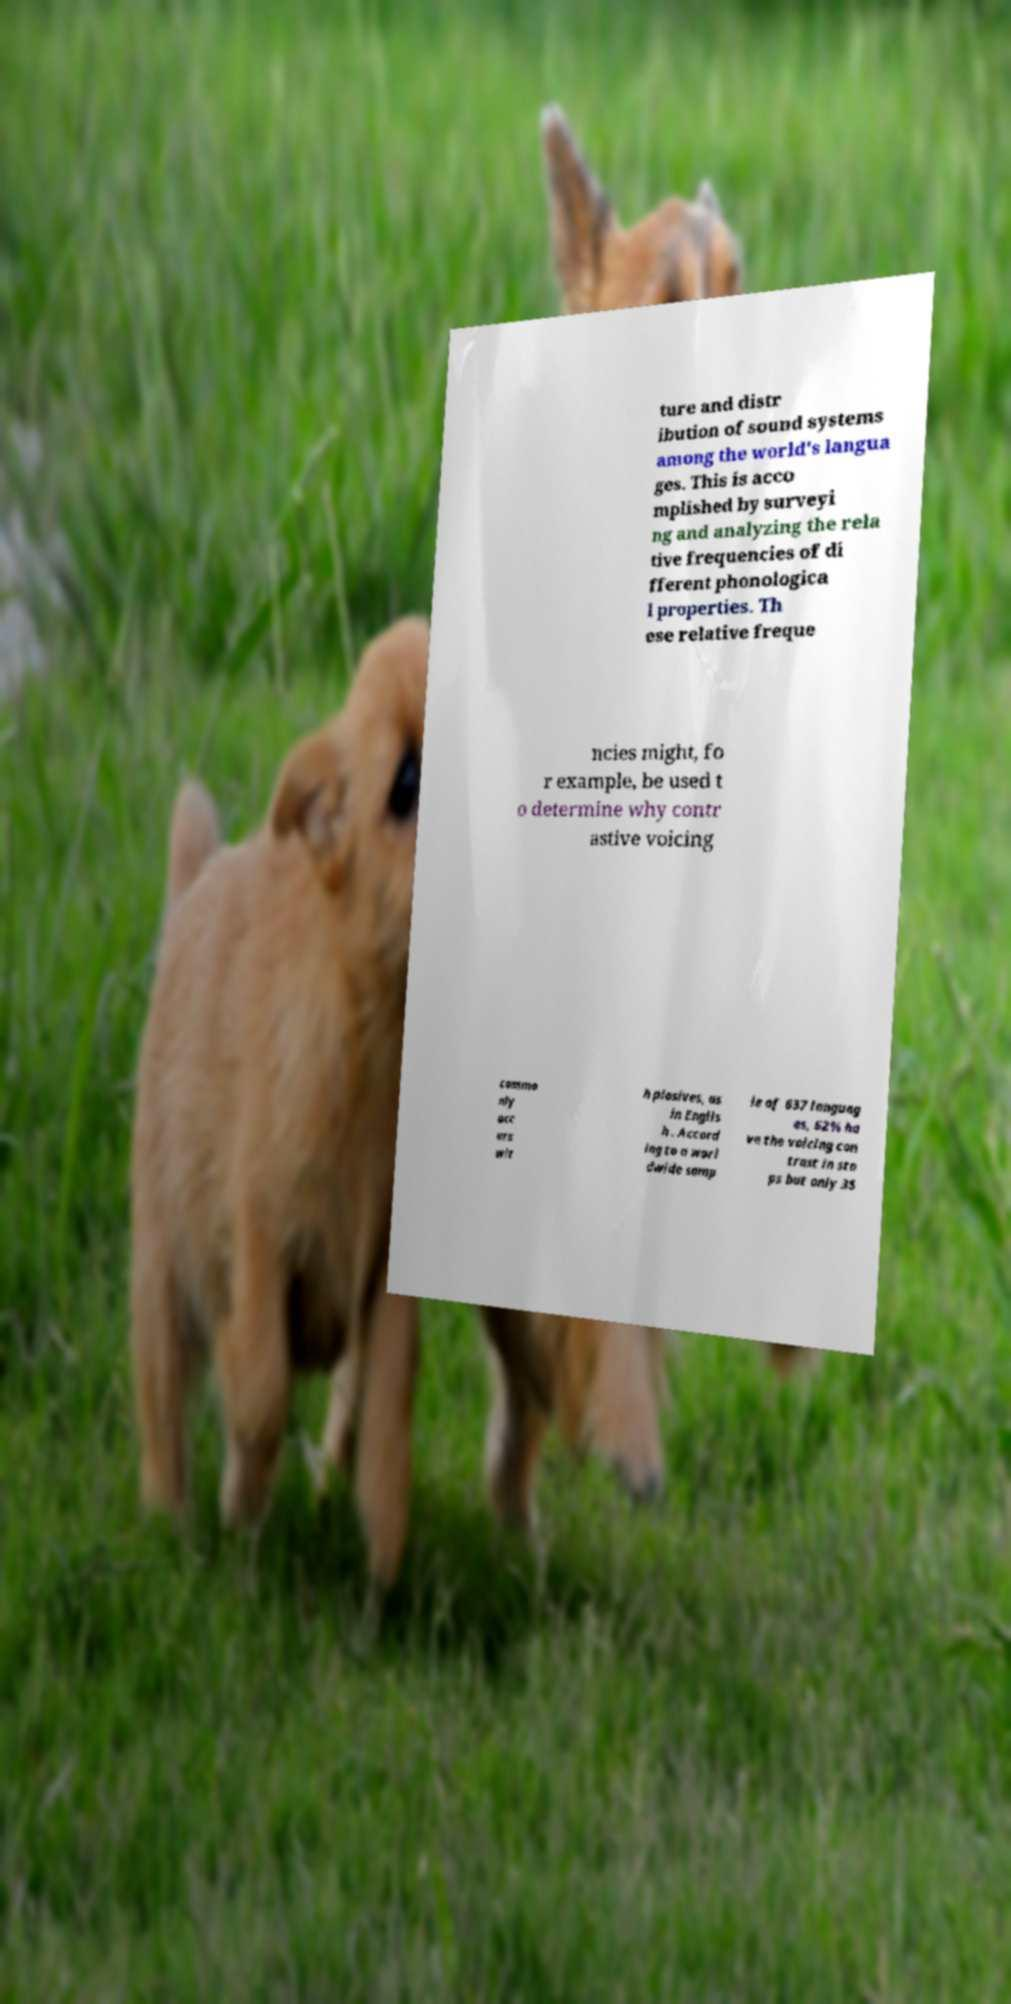Could you extract and type out the text from this image? ture and distr ibution of sound systems among the world's langua ges. This is acco mplished by surveyi ng and analyzing the rela tive frequencies of di fferent phonologica l properties. Th ese relative freque ncies might, fo r example, be used t o determine why contr astive voicing commo nly occ urs wit h plosives, as in Englis h . Accord ing to a worl dwide samp le of 637 languag es, 62% ha ve the voicing con trast in sto ps but only 35 